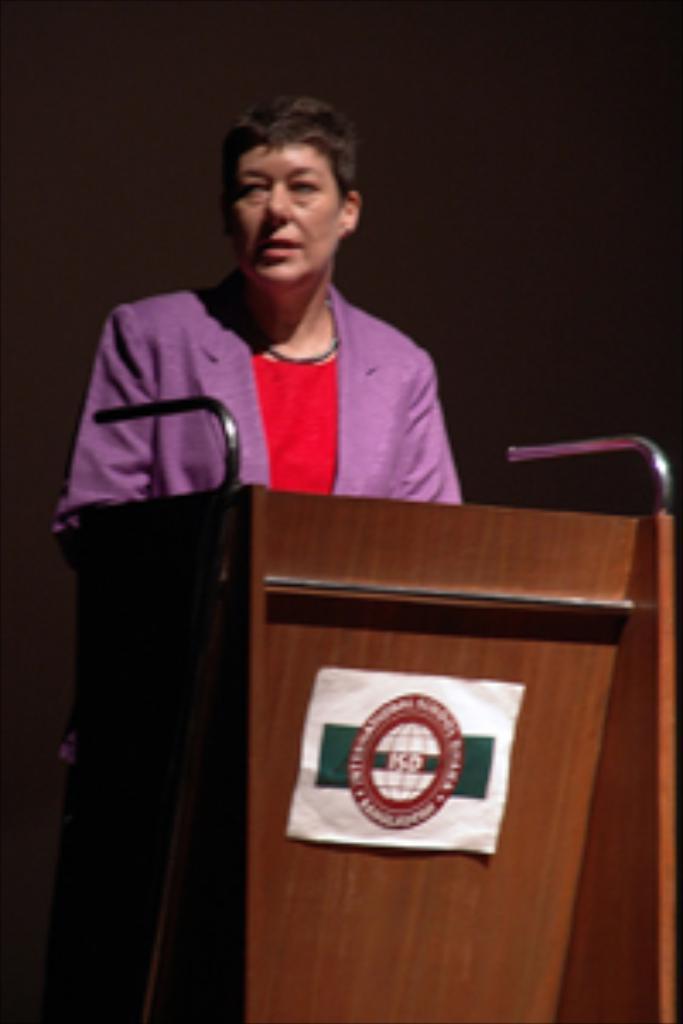Please provide a concise description of this image. In the center of the image a person is standing in-front of podium. In the background of the image there is a wall. 